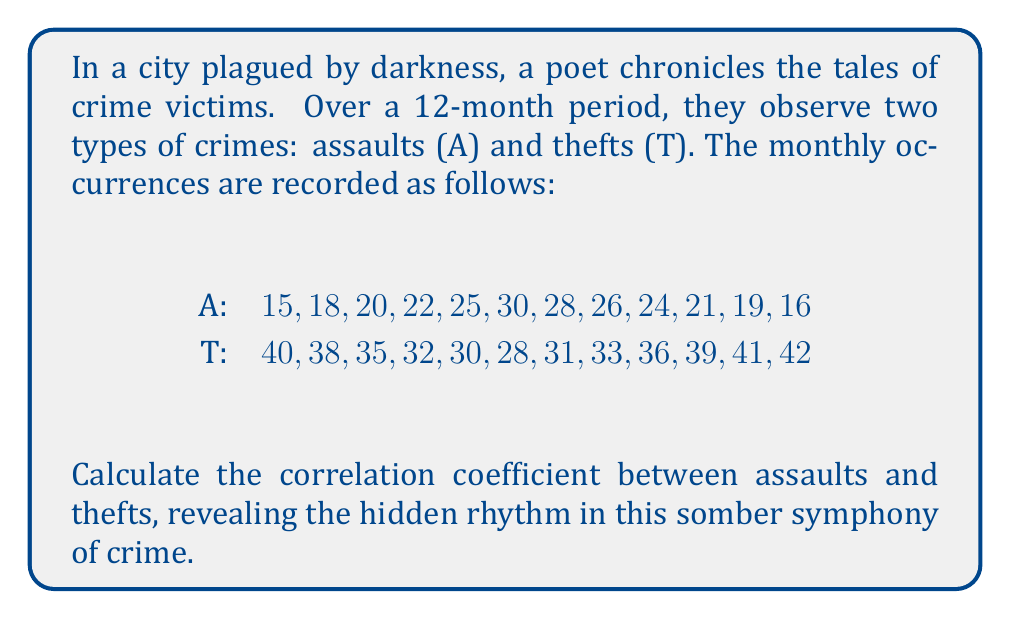Teach me how to tackle this problem. To calculate the correlation coefficient between assaults and thefts, we'll follow these steps:

1. Calculate the means of A and T:
   $\bar{A} = \frac{1}{12}\sum_{i=1}^{12} A_i = 22$
   $\bar{T} = \frac{1}{12}\sum_{i=1}^{12} T_i = 35.4167$

2. Calculate the deviations from the means:
   $a_i = A_i - \bar{A}$
   $t_i = T_i - \bar{T}$

3. Calculate the products of the deviations:
   $a_i t_i$

4. Sum the products of deviations:
   $\sum_{i=1}^{12} a_i t_i = -651.5$

5. Calculate the standard deviations:
   $s_A = \sqrt{\frac{1}{11}\sum_{i=1}^{12} (A_i - \bar{A})^2} = 4.7799$
   $s_T = \sqrt{\frac{1}{11}\sum_{i=1}^{12} (T_i - \bar{T})^2} = 4.6925$

6. Calculate the correlation coefficient:
   $$r = \frac{\sum_{i=1}^{12} a_i t_i}{12 s_A s_T}$$

7. Substitute the values:
   $$r = \frac{-651.5}{12 \cdot 4.7799 \cdot 4.6925} = -0.9709$$

The correlation coefficient ranges from -1 to 1, where -1 indicates a perfect negative correlation, 0 indicates no correlation, and 1 indicates a perfect positive correlation.
Answer: $r = -0.9709$ 